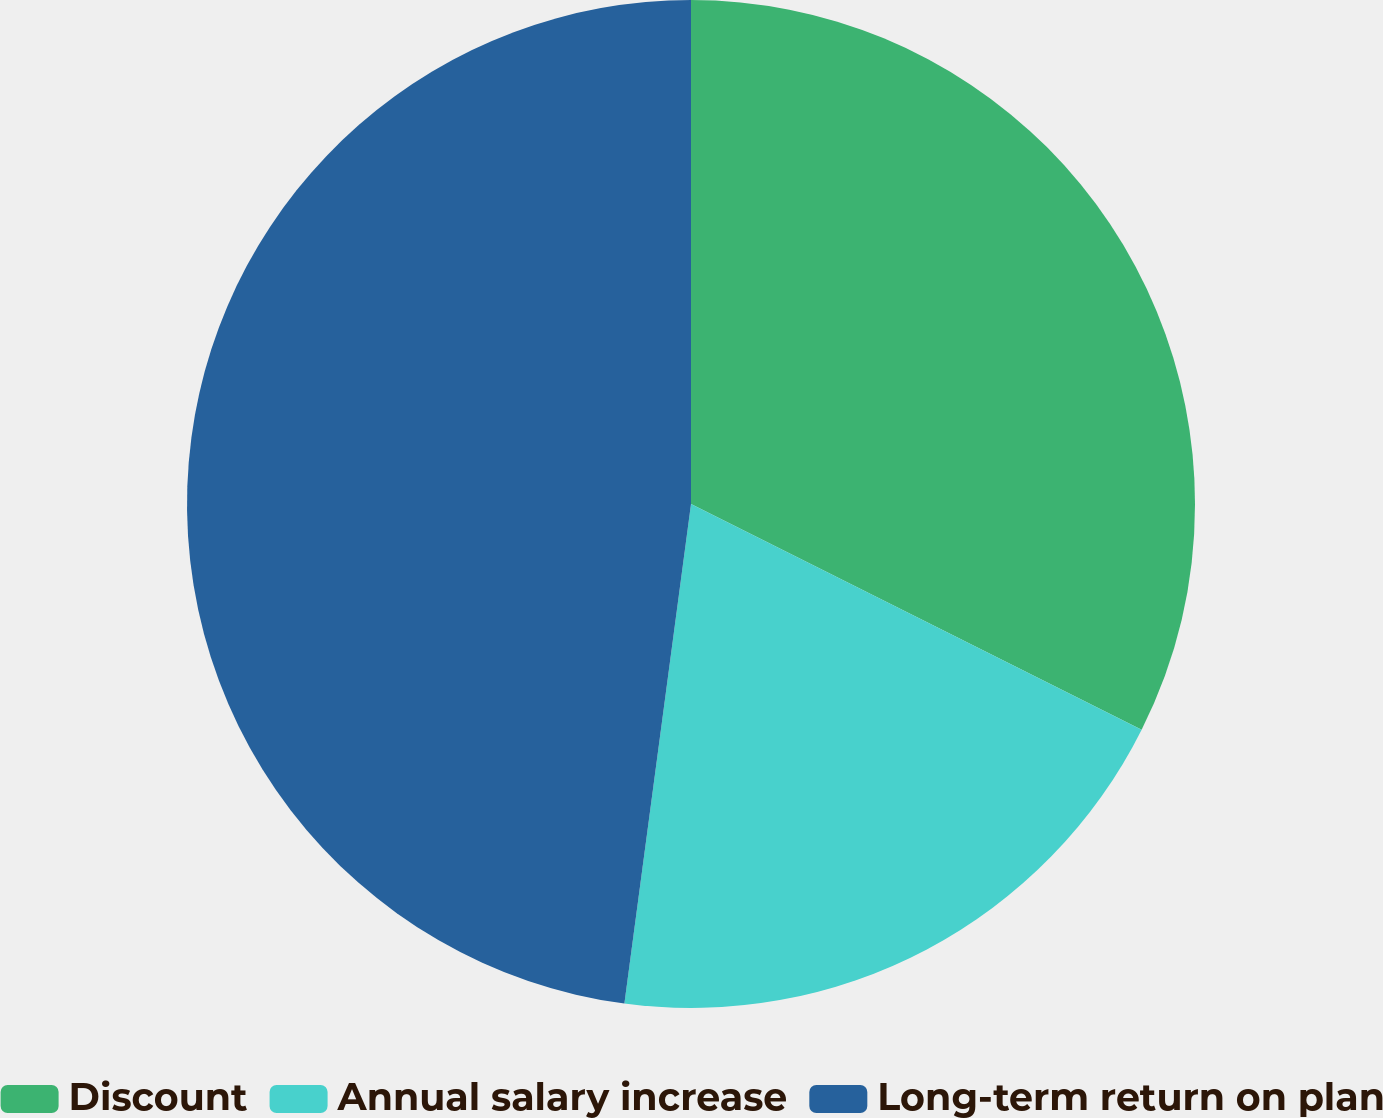Convert chart. <chart><loc_0><loc_0><loc_500><loc_500><pie_chart><fcel>Discount<fcel>Annual salary increase<fcel>Long-term return on plan<nl><fcel>32.39%<fcel>19.72%<fcel>47.89%<nl></chart> 